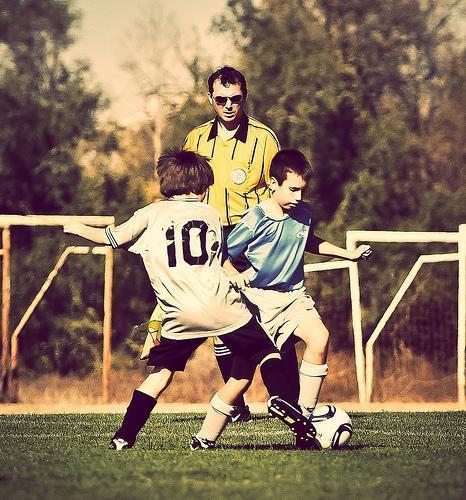How many kids are there?
Give a very brief answer. 2. How many balls are there?
Give a very brief answer. 1. 